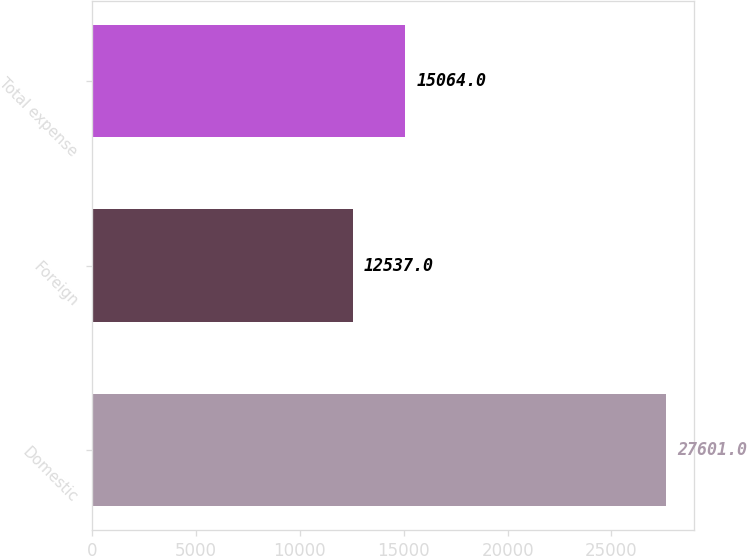Convert chart. <chart><loc_0><loc_0><loc_500><loc_500><bar_chart><fcel>Domestic<fcel>Foreign<fcel>Total expense<nl><fcel>27601<fcel>12537<fcel>15064<nl></chart> 